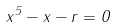<formula> <loc_0><loc_0><loc_500><loc_500>x ^ { 5 } - x - r = 0</formula> 